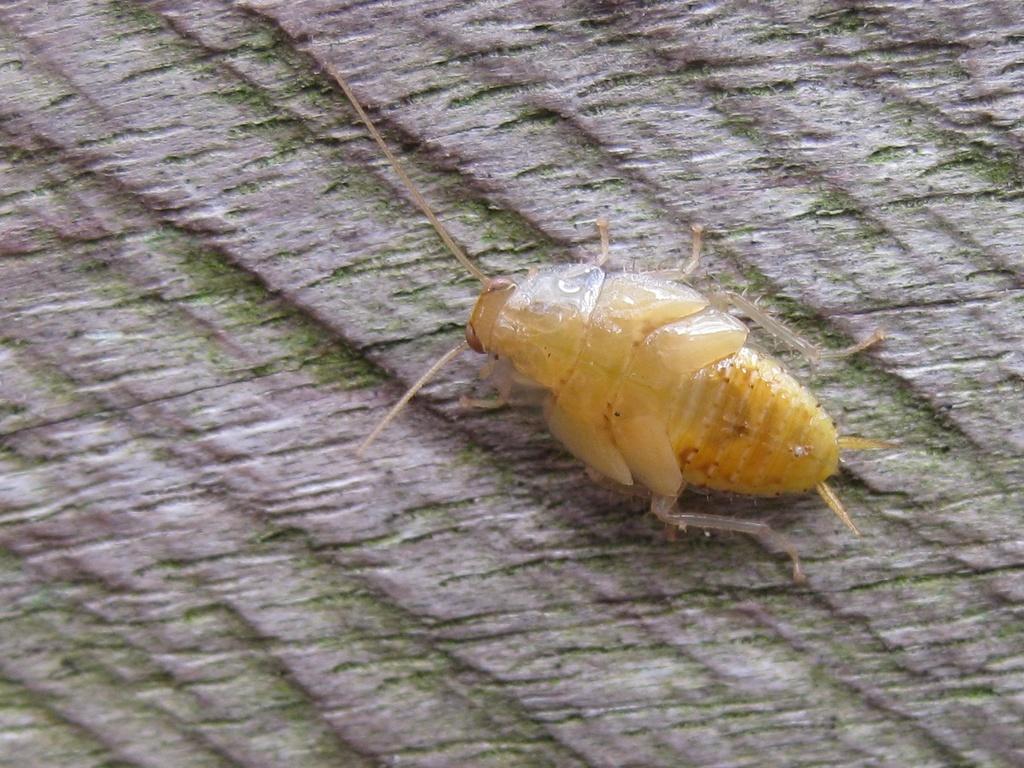Please provide a concise description of this image. In this image I can see an insect on a bark of a tree. 